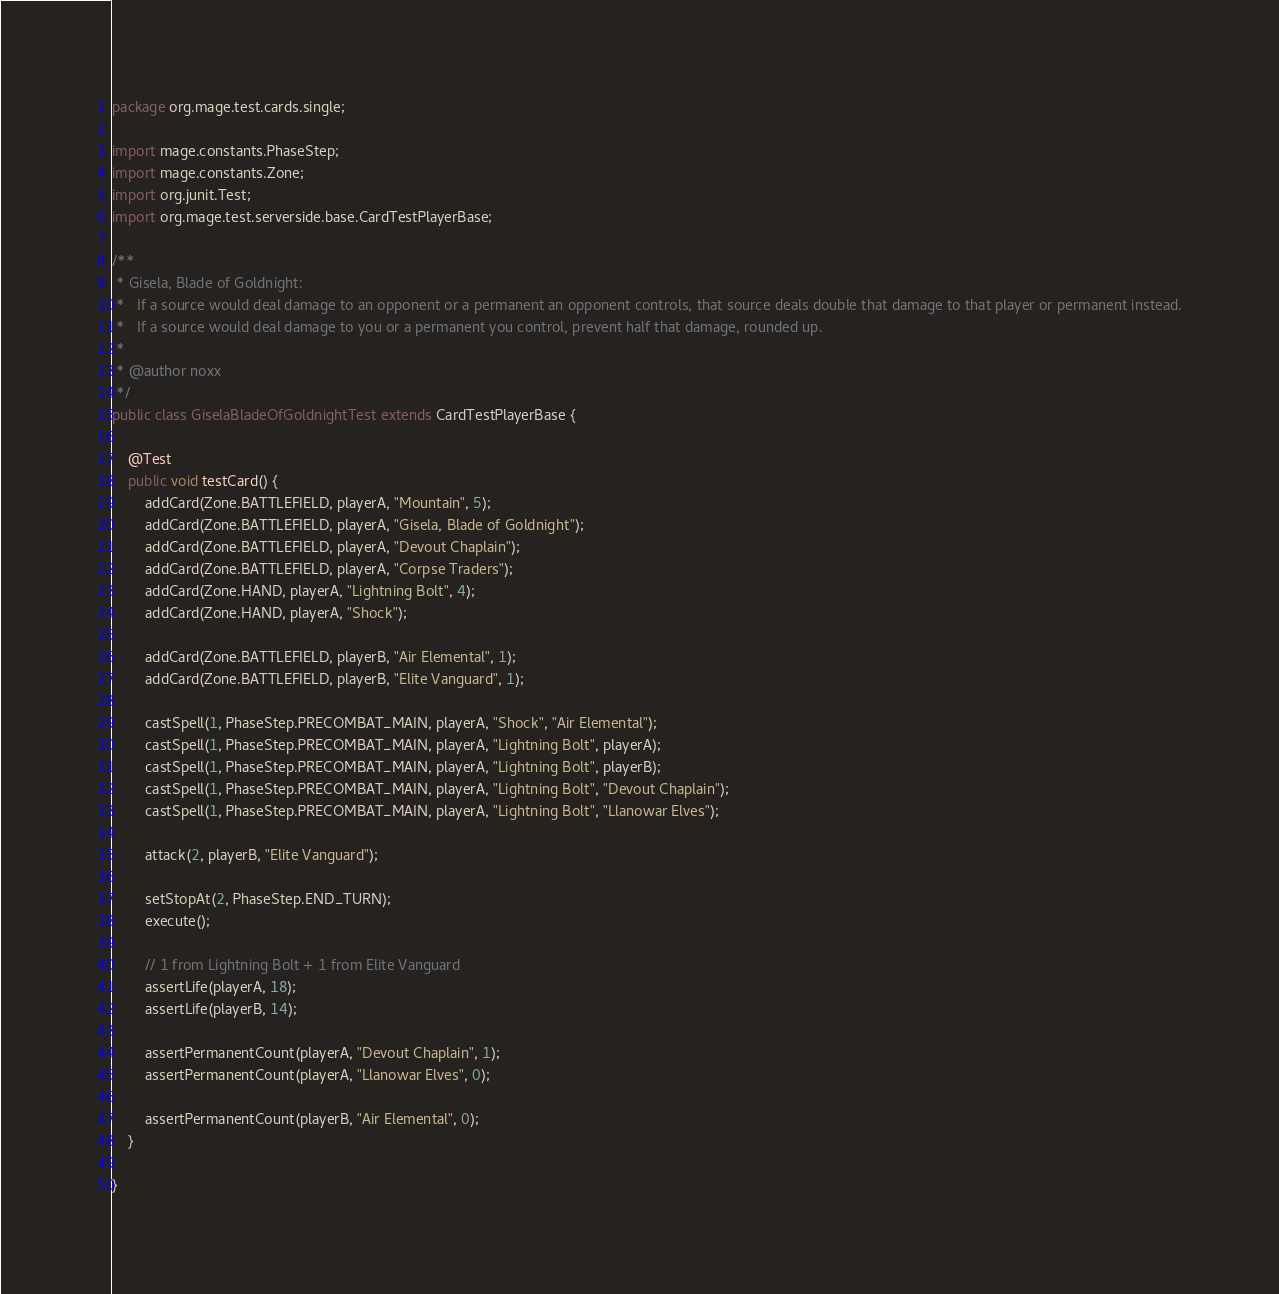<code> <loc_0><loc_0><loc_500><loc_500><_Java_>package org.mage.test.cards.single;

import mage.constants.PhaseStep;
import mage.constants.Zone;
import org.junit.Test;
import org.mage.test.serverside.base.CardTestPlayerBase;

/**
 * Gisela, Blade of Goldnight:
 *   If a source would deal damage to an opponent or a permanent an opponent controls, that source deals double that damage to that player or permanent instead.
 *   If a source would deal damage to you or a permanent you control, prevent half that damage, rounded up.
 *
 * @author noxx
 */
public class GiselaBladeOfGoldnightTest extends CardTestPlayerBase {

    @Test
    public void testCard() {
        addCard(Zone.BATTLEFIELD, playerA, "Mountain", 5);
        addCard(Zone.BATTLEFIELD, playerA, "Gisela, Blade of Goldnight");
        addCard(Zone.BATTLEFIELD, playerA, "Devout Chaplain");
        addCard(Zone.BATTLEFIELD, playerA, "Corpse Traders");
        addCard(Zone.HAND, playerA, "Lightning Bolt", 4);
        addCard(Zone.HAND, playerA, "Shock");

        addCard(Zone.BATTLEFIELD, playerB, "Air Elemental", 1);
        addCard(Zone.BATTLEFIELD, playerB, "Elite Vanguard", 1);

        castSpell(1, PhaseStep.PRECOMBAT_MAIN, playerA, "Shock", "Air Elemental");
        castSpell(1, PhaseStep.PRECOMBAT_MAIN, playerA, "Lightning Bolt", playerA);
        castSpell(1, PhaseStep.PRECOMBAT_MAIN, playerA, "Lightning Bolt", playerB);
        castSpell(1, PhaseStep.PRECOMBAT_MAIN, playerA, "Lightning Bolt", "Devout Chaplain");
        castSpell(1, PhaseStep.PRECOMBAT_MAIN, playerA, "Lightning Bolt", "Llanowar Elves");

        attack(2, playerB, "Elite Vanguard");

        setStopAt(2, PhaseStep.END_TURN);
        execute();

        // 1 from Lightning Bolt + 1 from Elite Vanguard
        assertLife(playerA, 18);
        assertLife(playerB, 14);

        assertPermanentCount(playerA, "Devout Chaplain", 1);
        assertPermanentCount(playerA, "Llanowar Elves", 0);

        assertPermanentCount(playerB, "Air Elemental", 0);
    }

}
</code> 